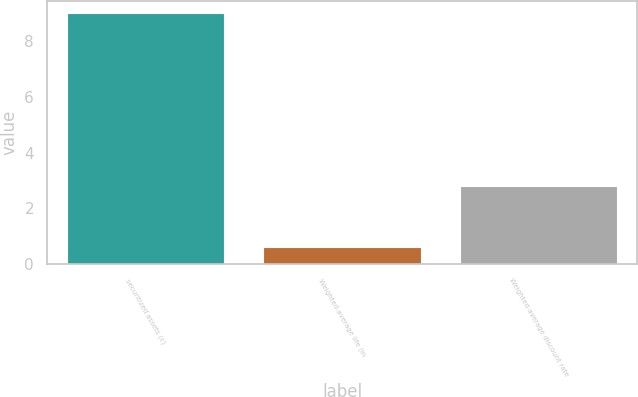Convert chart to OTSL. <chart><loc_0><loc_0><loc_500><loc_500><bar_chart><fcel>securitized assets (c)<fcel>Weighted-average life (in<fcel>Weighted-average discount rate<nl><fcel>9<fcel>0.6<fcel>2.8<nl></chart> 